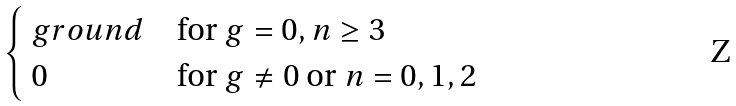<formula> <loc_0><loc_0><loc_500><loc_500>\begin{cases} \ g r o u n d & \text {for $g=0, n\geq 3$} \\ $ 0 $ & \text {for $g\neq 0$ or $n=0,1,2$} \end{cases}</formula> 